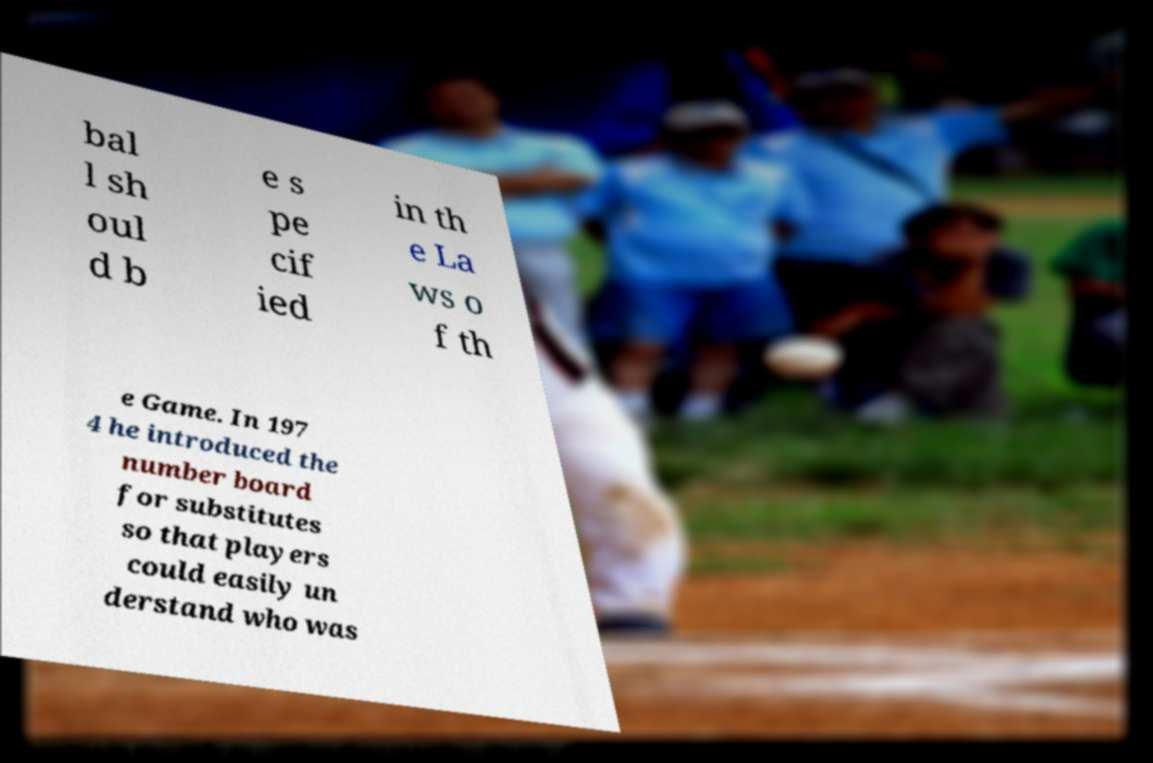Can you read and provide the text displayed in the image?This photo seems to have some interesting text. Can you extract and type it out for me? bal l sh oul d b e s pe cif ied in th e La ws o f th e Game. In 197 4 he introduced the number board for substitutes so that players could easily un derstand who was 